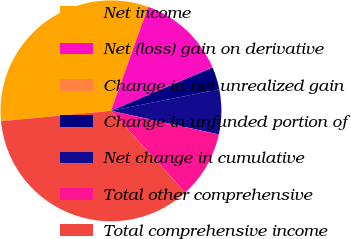Convert chart. <chart><loc_0><loc_0><loc_500><loc_500><pie_chart><fcel>Net income<fcel>Net (loss) gain on derivative<fcel>Change in net unrealized gain<fcel>Change in unfunded portion of<fcel>Net change in cumulative<fcel>Total other comprehensive<fcel>Total comprehensive income<nl><fcel>31.97%<fcel>13.09%<fcel>0.02%<fcel>3.29%<fcel>6.56%<fcel>9.83%<fcel>35.24%<nl></chart> 